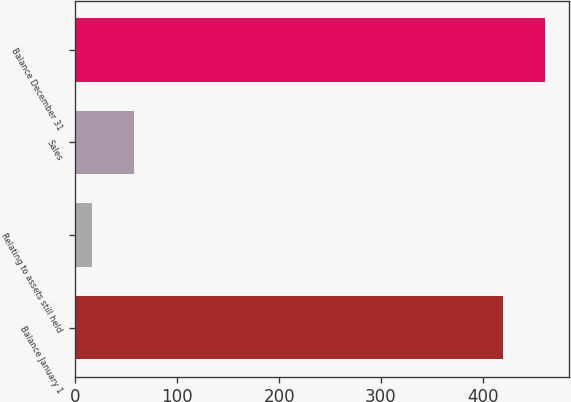<chart> <loc_0><loc_0><loc_500><loc_500><bar_chart><fcel>Balance January 1<fcel>Relating to assets still held<fcel>Sales<fcel>Balance December 31<nl><fcel>420<fcel>16<fcel>57.2<fcel>461.2<nl></chart> 